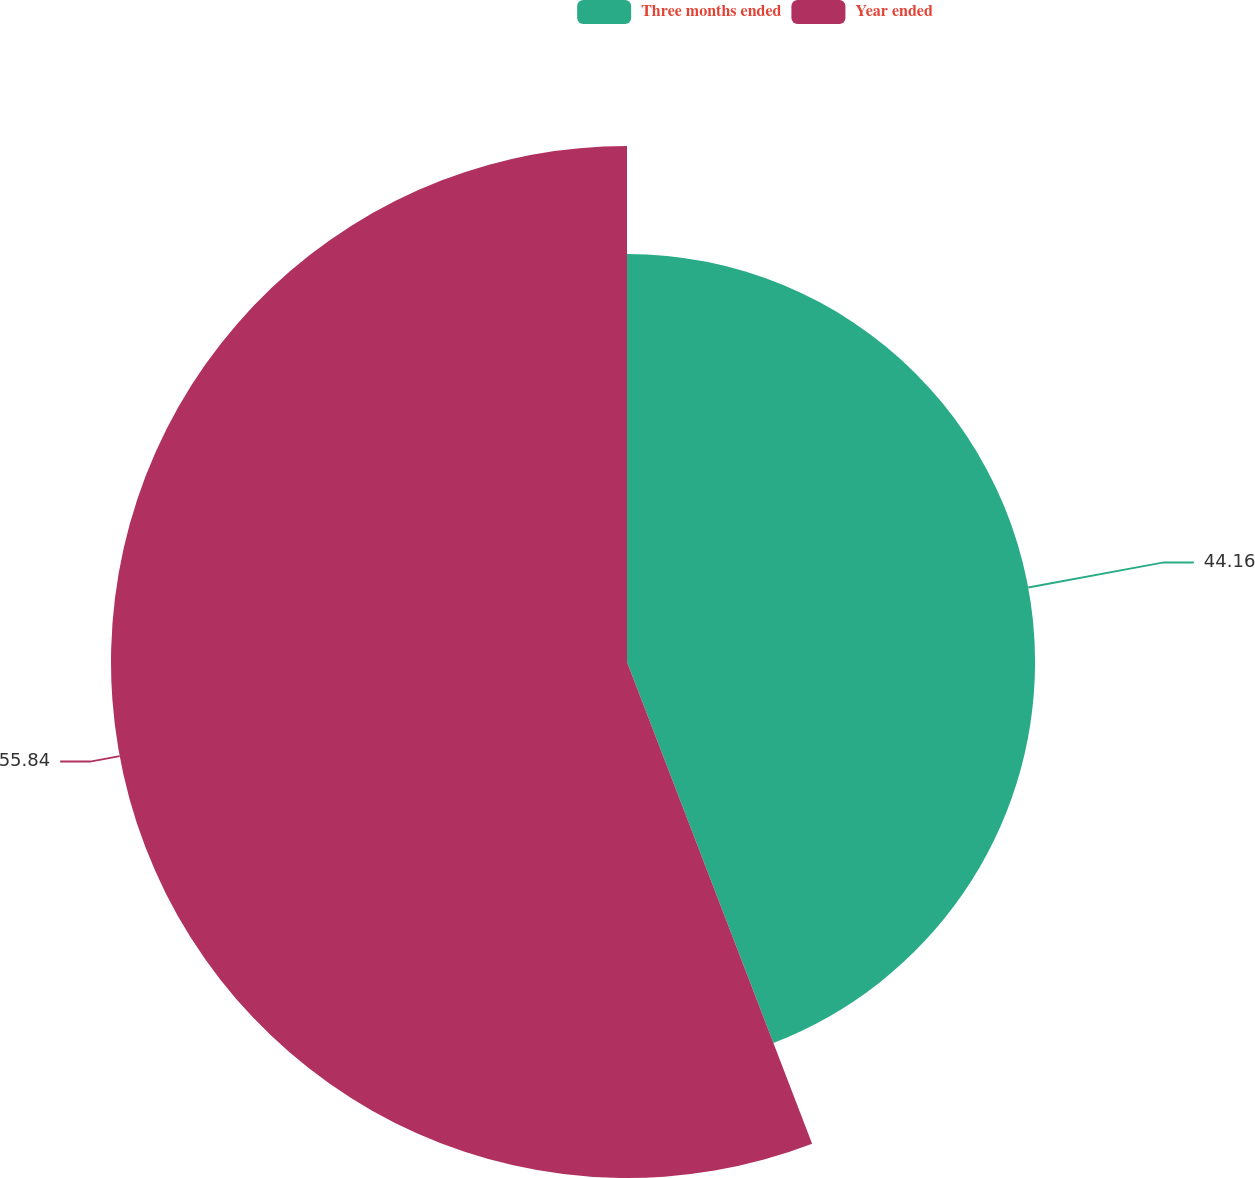Convert chart to OTSL. <chart><loc_0><loc_0><loc_500><loc_500><pie_chart><fcel>Three months ended<fcel>Year ended<nl><fcel>44.16%<fcel>55.84%<nl></chart> 